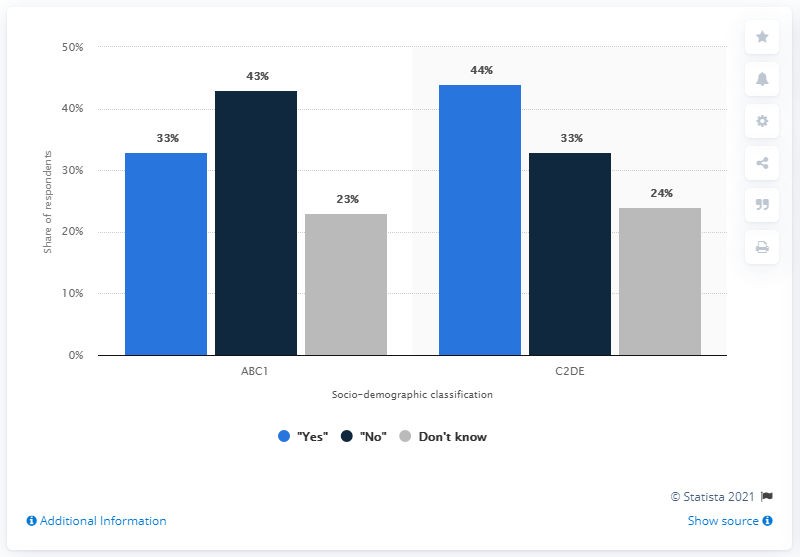Give some essential details in this illustration. The predominantly group that was composed of those who were in the "no" camp was ABC1. 